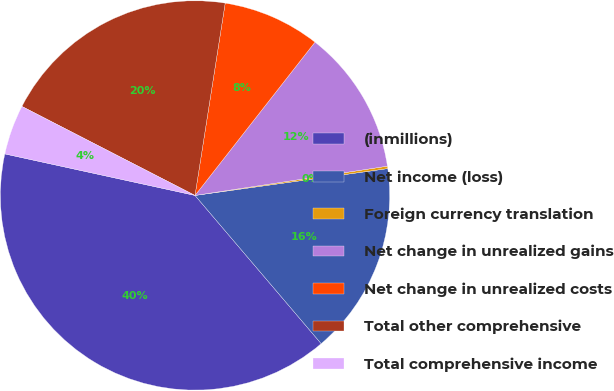Convert chart to OTSL. <chart><loc_0><loc_0><loc_500><loc_500><pie_chart><fcel>(inmillions)<fcel>Net income (loss)<fcel>Foreign currency translation<fcel>Net change in unrealized gains<fcel>Net change in unrealized costs<fcel>Total other comprehensive<fcel>Total comprehensive income<nl><fcel>39.65%<fcel>15.98%<fcel>0.2%<fcel>12.03%<fcel>8.09%<fcel>19.92%<fcel>4.14%<nl></chart> 